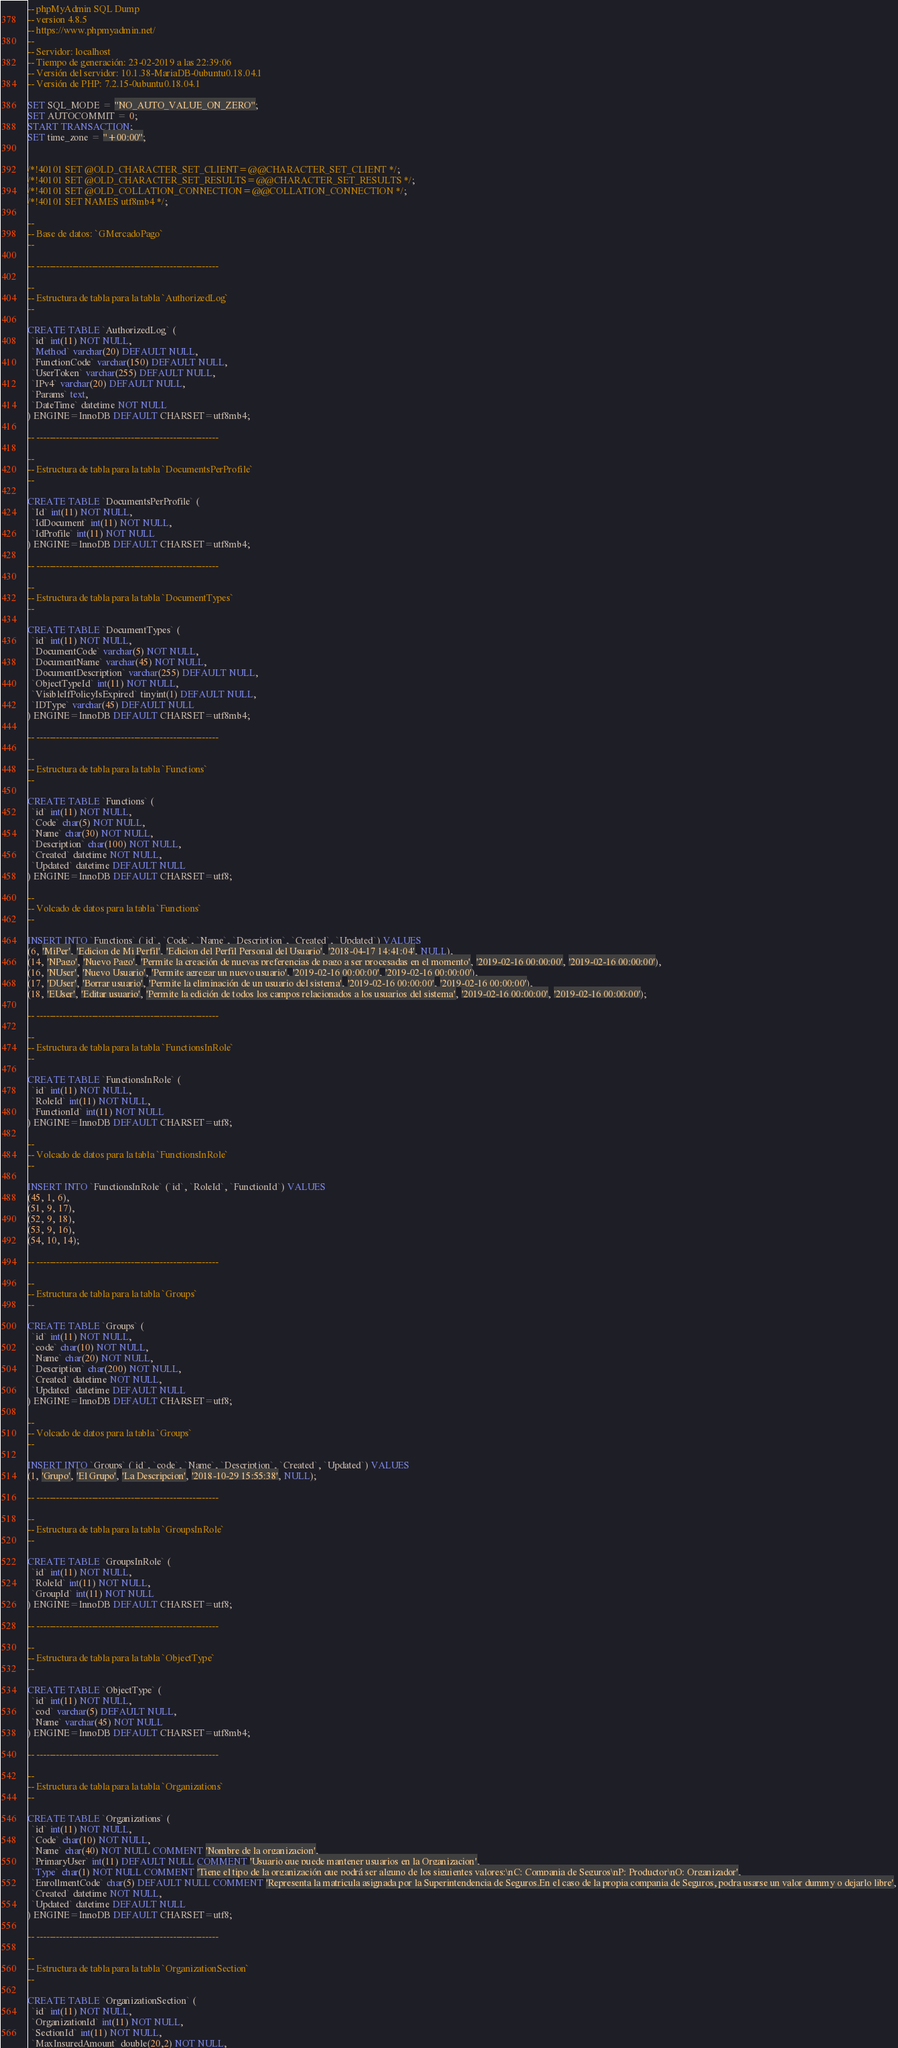Convert code to text. <code><loc_0><loc_0><loc_500><loc_500><_SQL_>-- phpMyAdmin SQL Dump
-- version 4.8.5
-- https://www.phpmyadmin.net/
--
-- Servidor: localhost
-- Tiempo de generación: 23-02-2019 a las 22:39:06
-- Versión del servidor: 10.1.38-MariaDB-0ubuntu0.18.04.1
-- Versión de PHP: 7.2.15-0ubuntu0.18.04.1

SET SQL_MODE = "NO_AUTO_VALUE_ON_ZERO";
SET AUTOCOMMIT = 0;
START TRANSACTION;
SET time_zone = "+00:00";


/*!40101 SET @OLD_CHARACTER_SET_CLIENT=@@CHARACTER_SET_CLIENT */;
/*!40101 SET @OLD_CHARACTER_SET_RESULTS=@@CHARACTER_SET_RESULTS */;
/*!40101 SET @OLD_COLLATION_CONNECTION=@@COLLATION_CONNECTION */;
/*!40101 SET NAMES utf8mb4 */;

--
-- Base de datos: `GMercadoPago`
--

-- --------------------------------------------------------

--
-- Estructura de tabla para la tabla `AuthorizedLog`
--

CREATE TABLE `AuthorizedLog` (
  `id` int(11) NOT NULL,
  `Method` varchar(20) DEFAULT NULL,
  `FunctionCode` varchar(150) DEFAULT NULL,
  `UserToken` varchar(255) DEFAULT NULL,
  `IPv4` varchar(20) DEFAULT NULL,
  `Params` text,
  `DateTime` datetime NOT NULL
) ENGINE=InnoDB DEFAULT CHARSET=utf8mb4;

-- --------------------------------------------------------

--
-- Estructura de tabla para la tabla `DocumentsPerProfile`
--

CREATE TABLE `DocumentsPerProfile` (
  `Id` int(11) NOT NULL,
  `IdDocument` int(11) NOT NULL,
  `IdProfile` int(11) NOT NULL
) ENGINE=InnoDB DEFAULT CHARSET=utf8mb4;

-- --------------------------------------------------------

--
-- Estructura de tabla para la tabla `DocumentTypes`
--

CREATE TABLE `DocumentTypes` (
  `id` int(11) NOT NULL,
  `DocumentCode` varchar(5) NOT NULL,
  `DocumentName` varchar(45) NOT NULL,
  `DocumentDescription` varchar(255) DEFAULT NULL,
  `ObjectTypeId` int(11) NOT NULL,
  `VisibleIfPolicyIsExpired` tinyint(1) DEFAULT NULL,
  `IDType` varchar(45) DEFAULT NULL
) ENGINE=InnoDB DEFAULT CHARSET=utf8mb4;

-- --------------------------------------------------------

--
-- Estructura de tabla para la tabla `Functions`
--

CREATE TABLE `Functions` (
  `id` int(11) NOT NULL,
  `Code` char(5) NOT NULL,
  `Name` char(30) NOT NULL,
  `Description` char(100) NOT NULL,
  `Created` datetime NOT NULL,
  `Updated` datetime DEFAULT NULL
) ENGINE=InnoDB DEFAULT CHARSET=utf8;

--
-- Volcado de datos para la tabla `Functions`
--

INSERT INTO `Functions` (`id`, `Code`, `Name`, `Description`, `Created`, `Updated`) VALUES
(6, 'MiPer', 'Edicion de Mi Perfil', 'Edicion del Perfil Personal del Usuario', '2018-04-17 14:41:04', NULL),
(14, 'NPago', 'Nuevo Pago', 'Permite la creación de nuevas preferencias de pago a ser procesadas en el momento', '2019-02-16 00:00:00', '2019-02-16 00:00:00'),
(16, 'NUser', 'Nuevo Usuario', 'Permite agregar un nuevo usuario', '2019-02-16 00:00:00', '2019-02-16 00:00:00'),
(17, 'DUser', 'Borrar usuario', 'Permite la eliminación de un usuario del sistema', '2019-02-16 00:00:00', '2019-02-16 00:00:00'),
(18, 'EUser', 'Editar usuario', 'Permite la edición de todos los campos relacionados a los usuarios del sistema', '2019-02-16 00:00:00', '2019-02-16 00:00:00');

-- --------------------------------------------------------

--
-- Estructura de tabla para la tabla `FunctionsInRole`
--

CREATE TABLE `FunctionsInRole` (
  `id` int(11) NOT NULL,
  `RoleId` int(11) NOT NULL,
  `FunctionId` int(11) NOT NULL
) ENGINE=InnoDB DEFAULT CHARSET=utf8;

--
-- Volcado de datos para la tabla `FunctionsInRole`
--

INSERT INTO `FunctionsInRole` (`id`, `RoleId`, `FunctionId`) VALUES
(45, 1, 6),
(51, 9, 17),
(52, 9, 18),
(53, 9, 16),
(54, 10, 14);

-- --------------------------------------------------------

--
-- Estructura de tabla para la tabla `Groups`
--

CREATE TABLE `Groups` (
  `id` int(11) NOT NULL,
  `code` char(10) NOT NULL,
  `Name` char(20) NOT NULL,
  `Description` char(200) NOT NULL,
  `Created` datetime NOT NULL,
  `Updated` datetime DEFAULT NULL
) ENGINE=InnoDB DEFAULT CHARSET=utf8;

--
-- Volcado de datos para la tabla `Groups`
--

INSERT INTO `Groups` (`id`, `code`, `Name`, `Description`, `Created`, `Updated`) VALUES
(1, 'Grupo', 'El Grupo', 'La Descripcion', '2018-10-29 15:55:38', NULL);

-- --------------------------------------------------------

--
-- Estructura de tabla para la tabla `GroupsInRole`
--

CREATE TABLE `GroupsInRole` (
  `id` int(11) NOT NULL,
  `RoleId` int(11) NOT NULL,
  `GroupId` int(11) NOT NULL
) ENGINE=InnoDB DEFAULT CHARSET=utf8;

-- --------------------------------------------------------

--
-- Estructura de tabla para la tabla `ObjectType`
--

CREATE TABLE `ObjectType` (
  `id` int(11) NOT NULL,
  `cod` varchar(5) DEFAULT NULL,
  `Name` varchar(45) NOT NULL
) ENGINE=InnoDB DEFAULT CHARSET=utf8mb4;

-- --------------------------------------------------------

--
-- Estructura de tabla para la tabla `Organizations`
--

CREATE TABLE `Organizations` (
  `id` int(11) NOT NULL,
  `Code` char(10) NOT NULL,
  `Name` char(40) NOT NULL COMMENT 'Nombre de la organizacion',
  `PrimaryUser` int(11) DEFAULT NULL COMMENT 'Usuario que puede mantener usuarios en la Organizacion',
  `Type` char(1) NOT NULL COMMENT 'Tiene el tipo de la organización que podrá ser alguno de los siguientes valores:\nC: Compania de Seguros\nP: Productor\nO: Organizador',
  `EnrollmentCode` char(5) DEFAULT NULL COMMENT 'Representa la matricula asignada por la Superintendencia de Seguros.En el caso de la propia compania de Seguros, podra usarse un valor dummy o dejarlo libre',
  `Created` datetime NOT NULL,
  `Updated` datetime DEFAULT NULL
) ENGINE=InnoDB DEFAULT CHARSET=utf8;

-- --------------------------------------------------------

--
-- Estructura de tabla para la tabla `OrganizationSection`
--

CREATE TABLE `OrganizationSection` (
  `id` int(11) NOT NULL,
  `OrganizationId` int(11) NOT NULL,
  `SectionId` int(11) NOT NULL,
  `MaxInsuredAmount` double(20,2) NOT NULL,</code> 